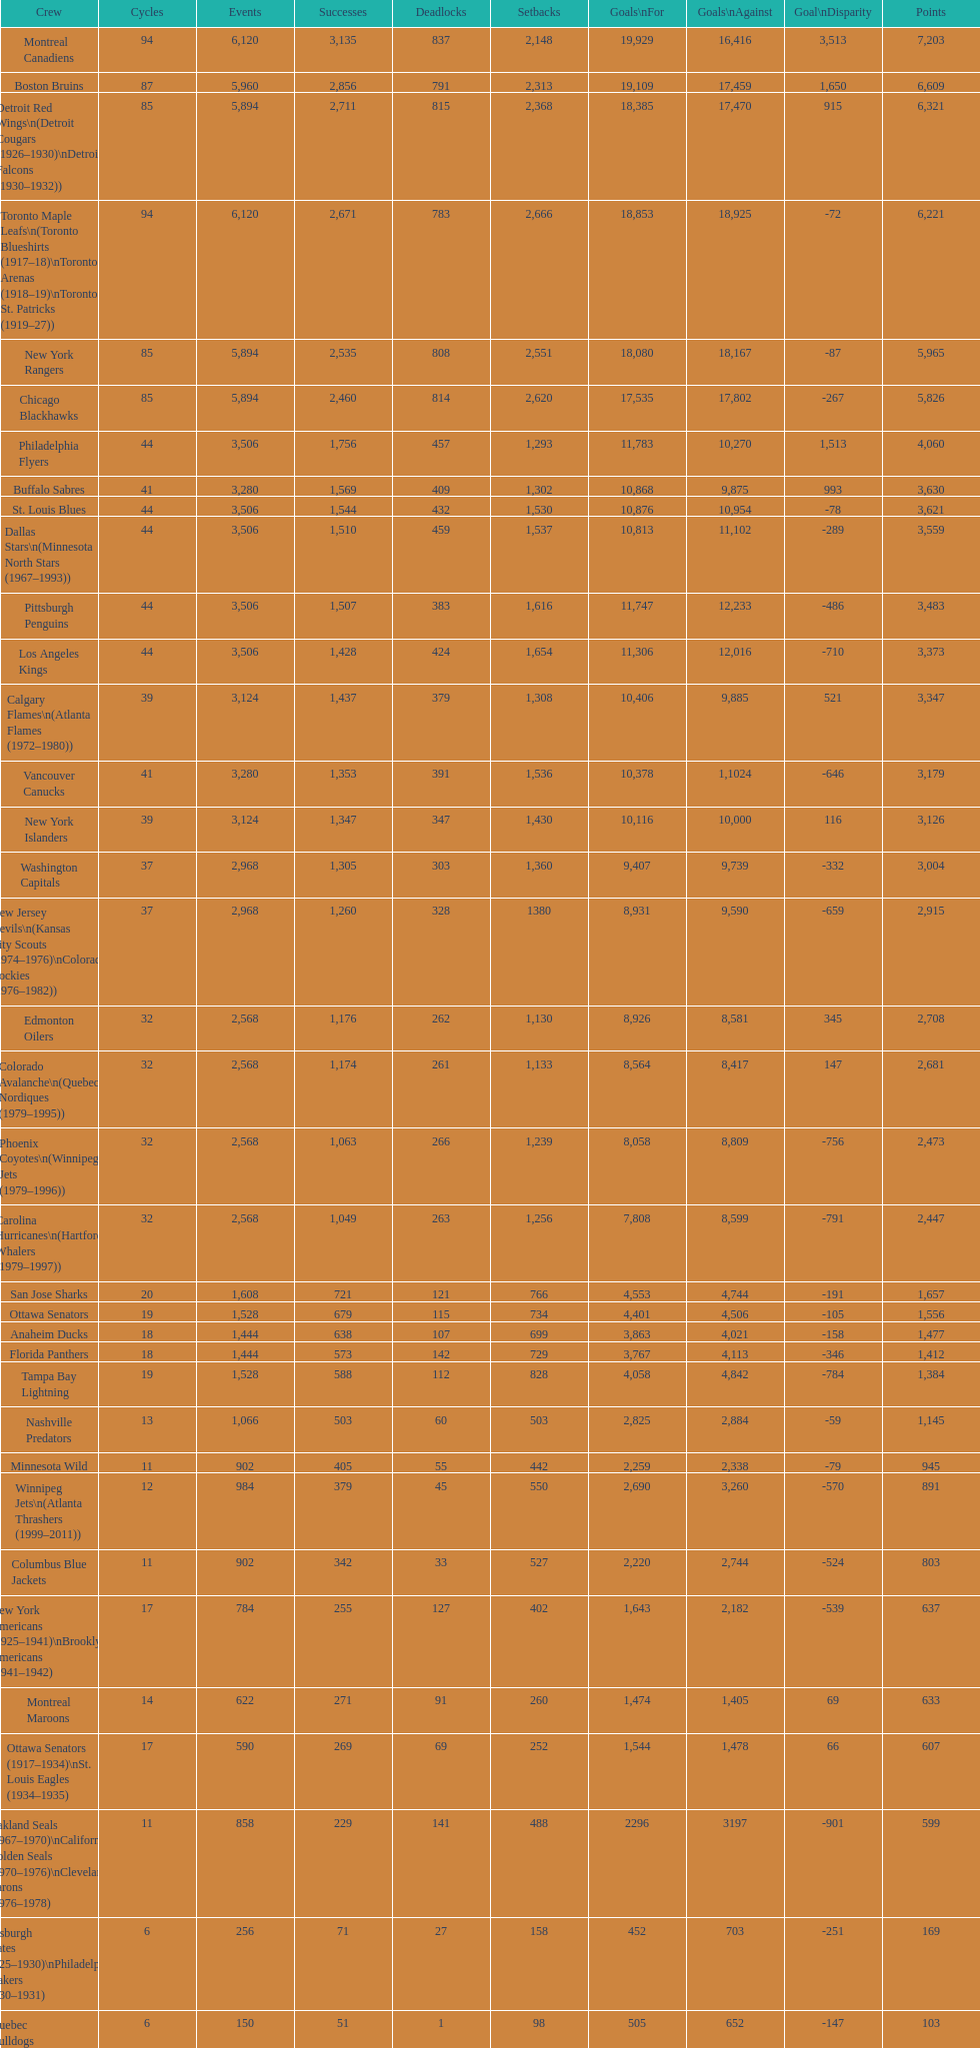Who has the least amount of losses? Montreal Wanderers. Could you help me parse every detail presented in this table? {'header': ['Crew', 'Cycles', 'Events', 'Successes', 'Deadlocks', 'Setbacks', 'Goals\\nFor', 'Goals\\nAgainst', 'Goal\\nDisparity', 'Points'], 'rows': [['Montreal Canadiens', '94', '6,120', '3,135', '837', '2,148', '19,929', '16,416', '3,513', '7,203'], ['Boston Bruins', '87', '5,960', '2,856', '791', '2,313', '19,109', '17,459', '1,650', '6,609'], ['Detroit Red Wings\\n(Detroit Cougars (1926–1930)\\nDetroit Falcons (1930–1932))', '85', '5,894', '2,711', '815', '2,368', '18,385', '17,470', '915', '6,321'], ['Toronto Maple Leafs\\n(Toronto Blueshirts (1917–18)\\nToronto Arenas (1918–19)\\nToronto St. Patricks (1919–27))', '94', '6,120', '2,671', '783', '2,666', '18,853', '18,925', '-72', '6,221'], ['New York Rangers', '85', '5,894', '2,535', '808', '2,551', '18,080', '18,167', '-87', '5,965'], ['Chicago Blackhawks', '85', '5,894', '2,460', '814', '2,620', '17,535', '17,802', '-267', '5,826'], ['Philadelphia Flyers', '44', '3,506', '1,756', '457', '1,293', '11,783', '10,270', '1,513', '4,060'], ['Buffalo Sabres', '41', '3,280', '1,569', '409', '1,302', '10,868', '9,875', '993', '3,630'], ['St. Louis Blues', '44', '3,506', '1,544', '432', '1,530', '10,876', '10,954', '-78', '3,621'], ['Dallas Stars\\n(Minnesota North Stars (1967–1993))', '44', '3,506', '1,510', '459', '1,537', '10,813', '11,102', '-289', '3,559'], ['Pittsburgh Penguins', '44', '3,506', '1,507', '383', '1,616', '11,747', '12,233', '-486', '3,483'], ['Los Angeles Kings', '44', '3,506', '1,428', '424', '1,654', '11,306', '12,016', '-710', '3,373'], ['Calgary Flames\\n(Atlanta Flames (1972–1980))', '39', '3,124', '1,437', '379', '1,308', '10,406', '9,885', '521', '3,347'], ['Vancouver Canucks', '41', '3,280', '1,353', '391', '1,536', '10,378', '1,1024', '-646', '3,179'], ['New York Islanders', '39', '3,124', '1,347', '347', '1,430', '10,116', '10,000', '116', '3,126'], ['Washington Capitals', '37', '2,968', '1,305', '303', '1,360', '9,407', '9,739', '-332', '3,004'], ['New Jersey Devils\\n(Kansas City Scouts (1974–1976)\\nColorado Rockies (1976–1982))', '37', '2,968', '1,260', '328', '1380', '8,931', '9,590', '-659', '2,915'], ['Edmonton Oilers', '32', '2,568', '1,176', '262', '1,130', '8,926', '8,581', '345', '2,708'], ['Colorado Avalanche\\n(Quebec Nordiques (1979–1995))', '32', '2,568', '1,174', '261', '1,133', '8,564', '8,417', '147', '2,681'], ['Phoenix Coyotes\\n(Winnipeg Jets (1979–1996))', '32', '2,568', '1,063', '266', '1,239', '8,058', '8,809', '-756', '2,473'], ['Carolina Hurricanes\\n(Hartford Whalers (1979–1997))', '32', '2,568', '1,049', '263', '1,256', '7,808', '8,599', '-791', '2,447'], ['San Jose Sharks', '20', '1,608', '721', '121', '766', '4,553', '4,744', '-191', '1,657'], ['Ottawa Senators', '19', '1,528', '679', '115', '734', '4,401', '4,506', '-105', '1,556'], ['Anaheim Ducks', '18', '1,444', '638', '107', '699', '3,863', '4,021', '-158', '1,477'], ['Florida Panthers', '18', '1,444', '573', '142', '729', '3,767', '4,113', '-346', '1,412'], ['Tampa Bay Lightning', '19', '1,528', '588', '112', '828', '4,058', '4,842', '-784', '1,384'], ['Nashville Predators', '13', '1,066', '503', '60', '503', '2,825', '2,884', '-59', '1,145'], ['Minnesota Wild', '11', '902', '405', '55', '442', '2,259', '2,338', '-79', '945'], ['Winnipeg Jets\\n(Atlanta Thrashers (1999–2011))', '12', '984', '379', '45', '550', '2,690', '3,260', '-570', '891'], ['Columbus Blue Jackets', '11', '902', '342', '33', '527', '2,220', '2,744', '-524', '803'], ['New York Americans (1925–1941)\\nBrooklyn Americans (1941–1942)', '17', '784', '255', '127', '402', '1,643', '2,182', '-539', '637'], ['Montreal Maroons', '14', '622', '271', '91', '260', '1,474', '1,405', '69', '633'], ['Ottawa Senators (1917–1934)\\nSt. Louis Eagles (1934–1935)', '17', '590', '269', '69', '252', '1,544', '1,478', '66', '607'], ['Oakland Seals (1967–1970)\\nCalifornia Golden Seals (1970–1976)\\nCleveland Barons (1976–1978)', '11', '858', '229', '141', '488', '2296', '3197', '-901', '599'], ['Pittsburgh Pirates (1925–1930)\\nPhiladelphia Quakers (1930–1931)', '6', '256', '71', '27', '158', '452', '703', '-251', '169'], ['Quebec Bulldogs (1919–1920)\\nHamilton Tigers (1920–1925)', '6', '150', '51', '1', '98', '505', '652', '-147', '103'], ['Montreal Wanderers', '1', '6', '1', '0', '5', '17', '35', '-18', '2']]} 